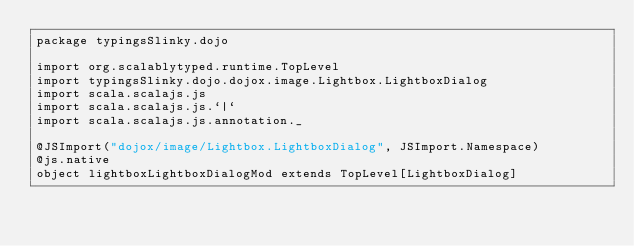Convert code to text. <code><loc_0><loc_0><loc_500><loc_500><_Scala_>package typingsSlinky.dojo

import org.scalablytyped.runtime.TopLevel
import typingsSlinky.dojo.dojox.image.Lightbox.LightboxDialog
import scala.scalajs.js
import scala.scalajs.js.`|`
import scala.scalajs.js.annotation._

@JSImport("dojox/image/Lightbox.LightboxDialog", JSImport.Namespace)
@js.native
object lightboxLightboxDialogMod extends TopLevel[LightboxDialog]

</code> 